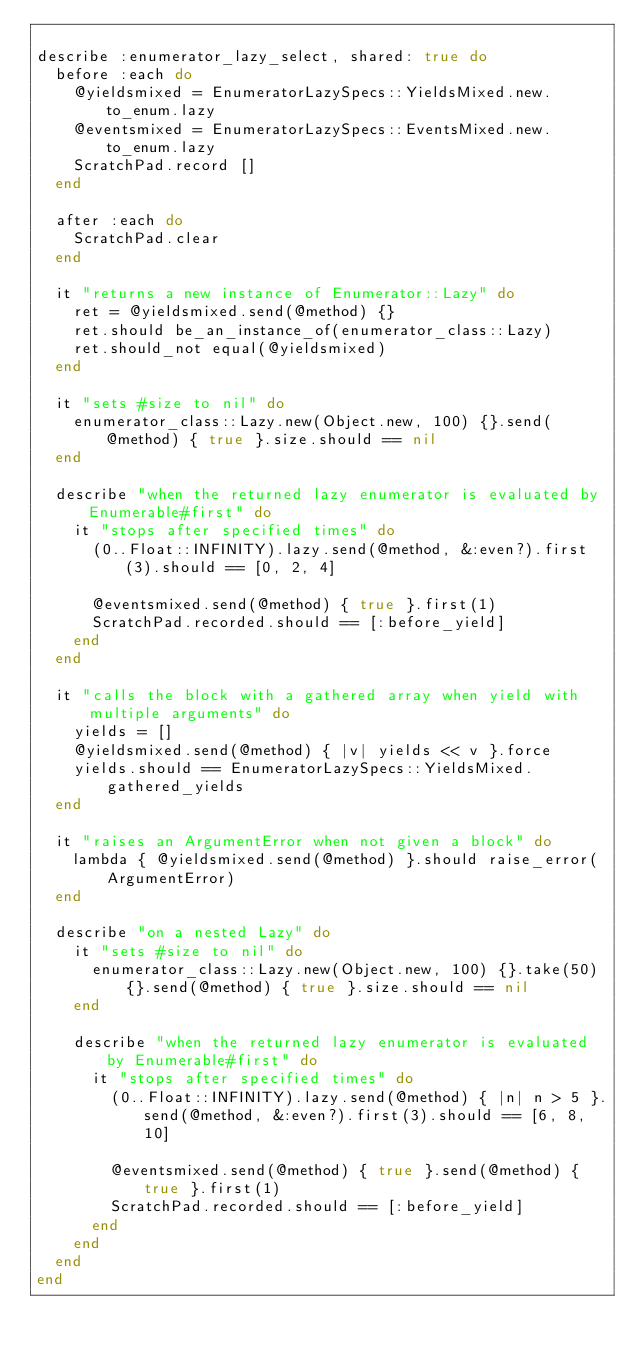Convert code to text. <code><loc_0><loc_0><loc_500><loc_500><_Ruby_>
describe :enumerator_lazy_select, shared: true do
  before :each do
    @yieldsmixed = EnumeratorLazySpecs::YieldsMixed.new.to_enum.lazy
    @eventsmixed = EnumeratorLazySpecs::EventsMixed.new.to_enum.lazy
    ScratchPad.record []
  end

  after :each do
    ScratchPad.clear
  end

  it "returns a new instance of Enumerator::Lazy" do
    ret = @yieldsmixed.send(@method) {}
    ret.should be_an_instance_of(enumerator_class::Lazy)
    ret.should_not equal(@yieldsmixed)
  end

  it "sets #size to nil" do
    enumerator_class::Lazy.new(Object.new, 100) {}.send(@method) { true }.size.should == nil
  end

  describe "when the returned lazy enumerator is evaluated by Enumerable#first" do
    it "stops after specified times" do
      (0..Float::INFINITY).lazy.send(@method, &:even?).first(3).should == [0, 2, 4]

      @eventsmixed.send(@method) { true }.first(1)
      ScratchPad.recorded.should == [:before_yield]
    end
  end

  it "calls the block with a gathered array when yield with multiple arguments" do
    yields = []
    @yieldsmixed.send(@method) { |v| yields << v }.force
    yields.should == EnumeratorLazySpecs::YieldsMixed.gathered_yields
  end

  it "raises an ArgumentError when not given a block" do
    lambda { @yieldsmixed.send(@method) }.should raise_error(ArgumentError)
  end

  describe "on a nested Lazy" do
    it "sets #size to nil" do
      enumerator_class::Lazy.new(Object.new, 100) {}.take(50) {}.send(@method) { true }.size.should == nil
    end

    describe "when the returned lazy enumerator is evaluated by Enumerable#first" do
      it "stops after specified times" do
        (0..Float::INFINITY).lazy.send(@method) { |n| n > 5 }.send(@method, &:even?).first(3).should == [6, 8, 10]

        @eventsmixed.send(@method) { true }.send(@method) { true }.first(1)
        ScratchPad.recorded.should == [:before_yield]
      end
    end
  end
end
</code> 